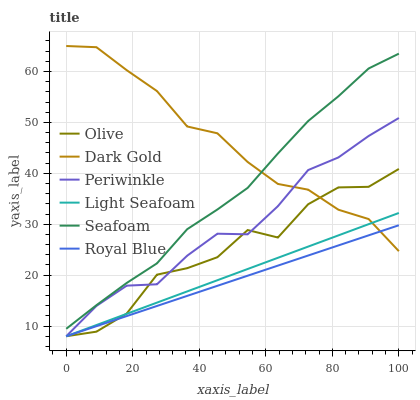Does Royal Blue have the minimum area under the curve?
Answer yes or no. Yes. Does Dark Gold have the maximum area under the curve?
Answer yes or no. Yes. Does Seafoam have the minimum area under the curve?
Answer yes or no. No. Does Seafoam have the maximum area under the curve?
Answer yes or no. No. Is Royal Blue the smoothest?
Answer yes or no. Yes. Is Olive the roughest?
Answer yes or no. Yes. Is Seafoam the smoothest?
Answer yes or no. No. Is Seafoam the roughest?
Answer yes or no. No. Does Royal Blue have the lowest value?
Answer yes or no. Yes. Does Seafoam have the lowest value?
Answer yes or no. No. Does Dark Gold have the highest value?
Answer yes or no. Yes. Does Seafoam have the highest value?
Answer yes or no. No. Is Olive less than Seafoam?
Answer yes or no. Yes. Is Seafoam greater than Royal Blue?
Answer yes or no. Yes. Does Light Seafoam intersect Royal Blue?
Answer yes or no. Yes. Is Light Seafoam less than Royal Blue?
Answer yes or no. No. Is Light Seafoam greater than Royal Blue?
Answer yes or no. No. Does Olive intersect Seafoam?
Answer yes or no. No. 